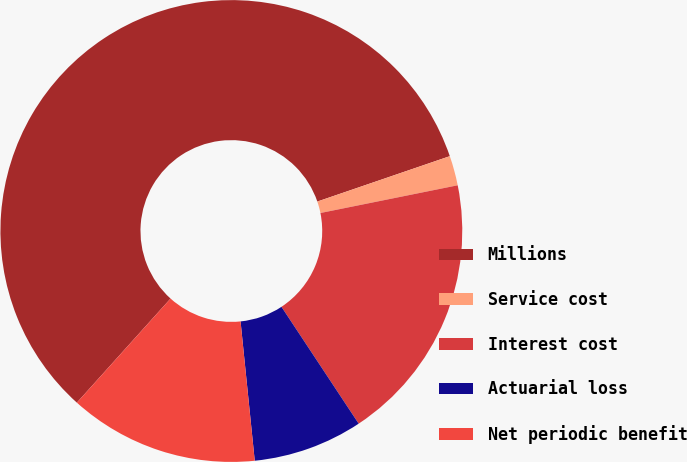Convert chart. <chart><loc_0><loc_0><loc_500><loc_500><pie_chart><fcel>Millions<fcel>Service cost<fcel>Interest cost<fcel>Actuarial loss<fcel>Net periodic benefit<nl><fcel>58.09%<fcel>2.08%<fcel>18.88%<fcel>7.68%<fcel>13.28%<nl></chart> 